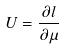Convert formula to latex. <formula><loc_0><loc_0><loc_500><loc_500>U = \frac { \partial l } { \partial \mu }</formula> 